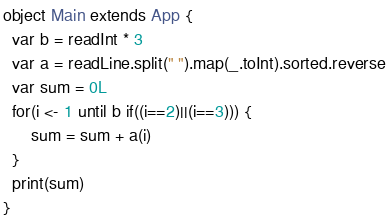<code> <loc_0><loc_0><loc_500><loc_500><_Scala_>object Main extends App {
  var b = readInt * 3
  var a = readLine.split(" ").map(_.toInt).sorted.reverse
  var sum = 0L
  for(i <- 1 until b if((i==2)||(i==3))) {
      sum = sum + a(i)
  }
  print(sum)
}</code> 